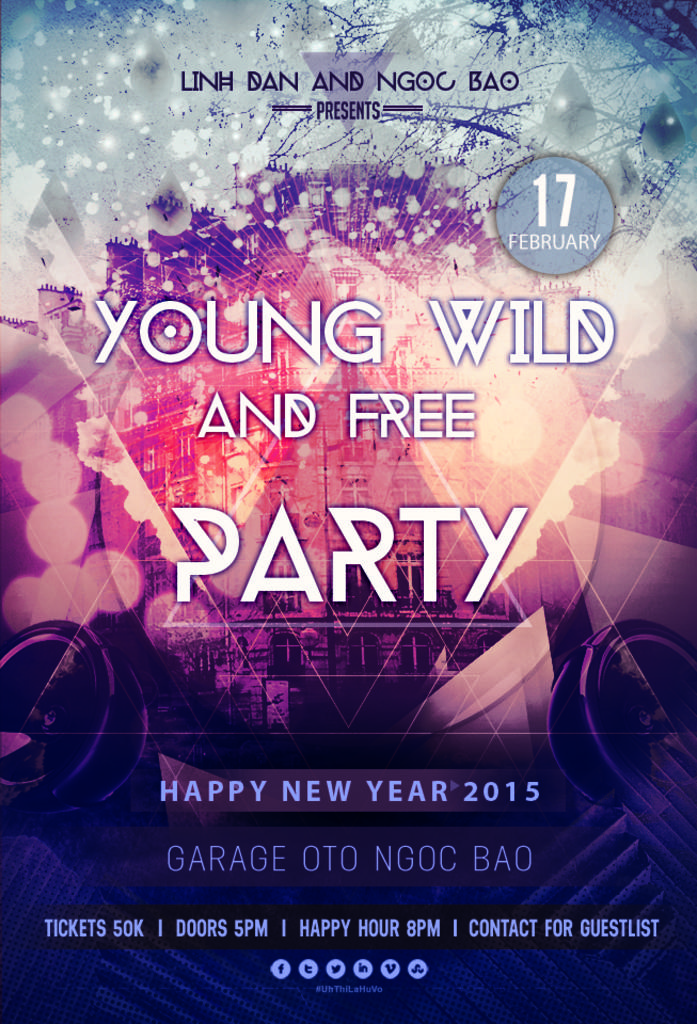What is the main subject of the image? There is an advertisement in the image. What can be found on the advertisement? There is text in the image. What is visible in the background of the image? There is a building in the background of the image. How many goldfish are swimming in the bubble in the image? There are no goldfish or bubbles present in the image. 